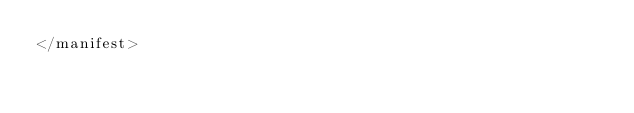Convert code to text. <code><loc_0><loc_0><loc_500><loc_500><_XML_></manifest>
</code> 